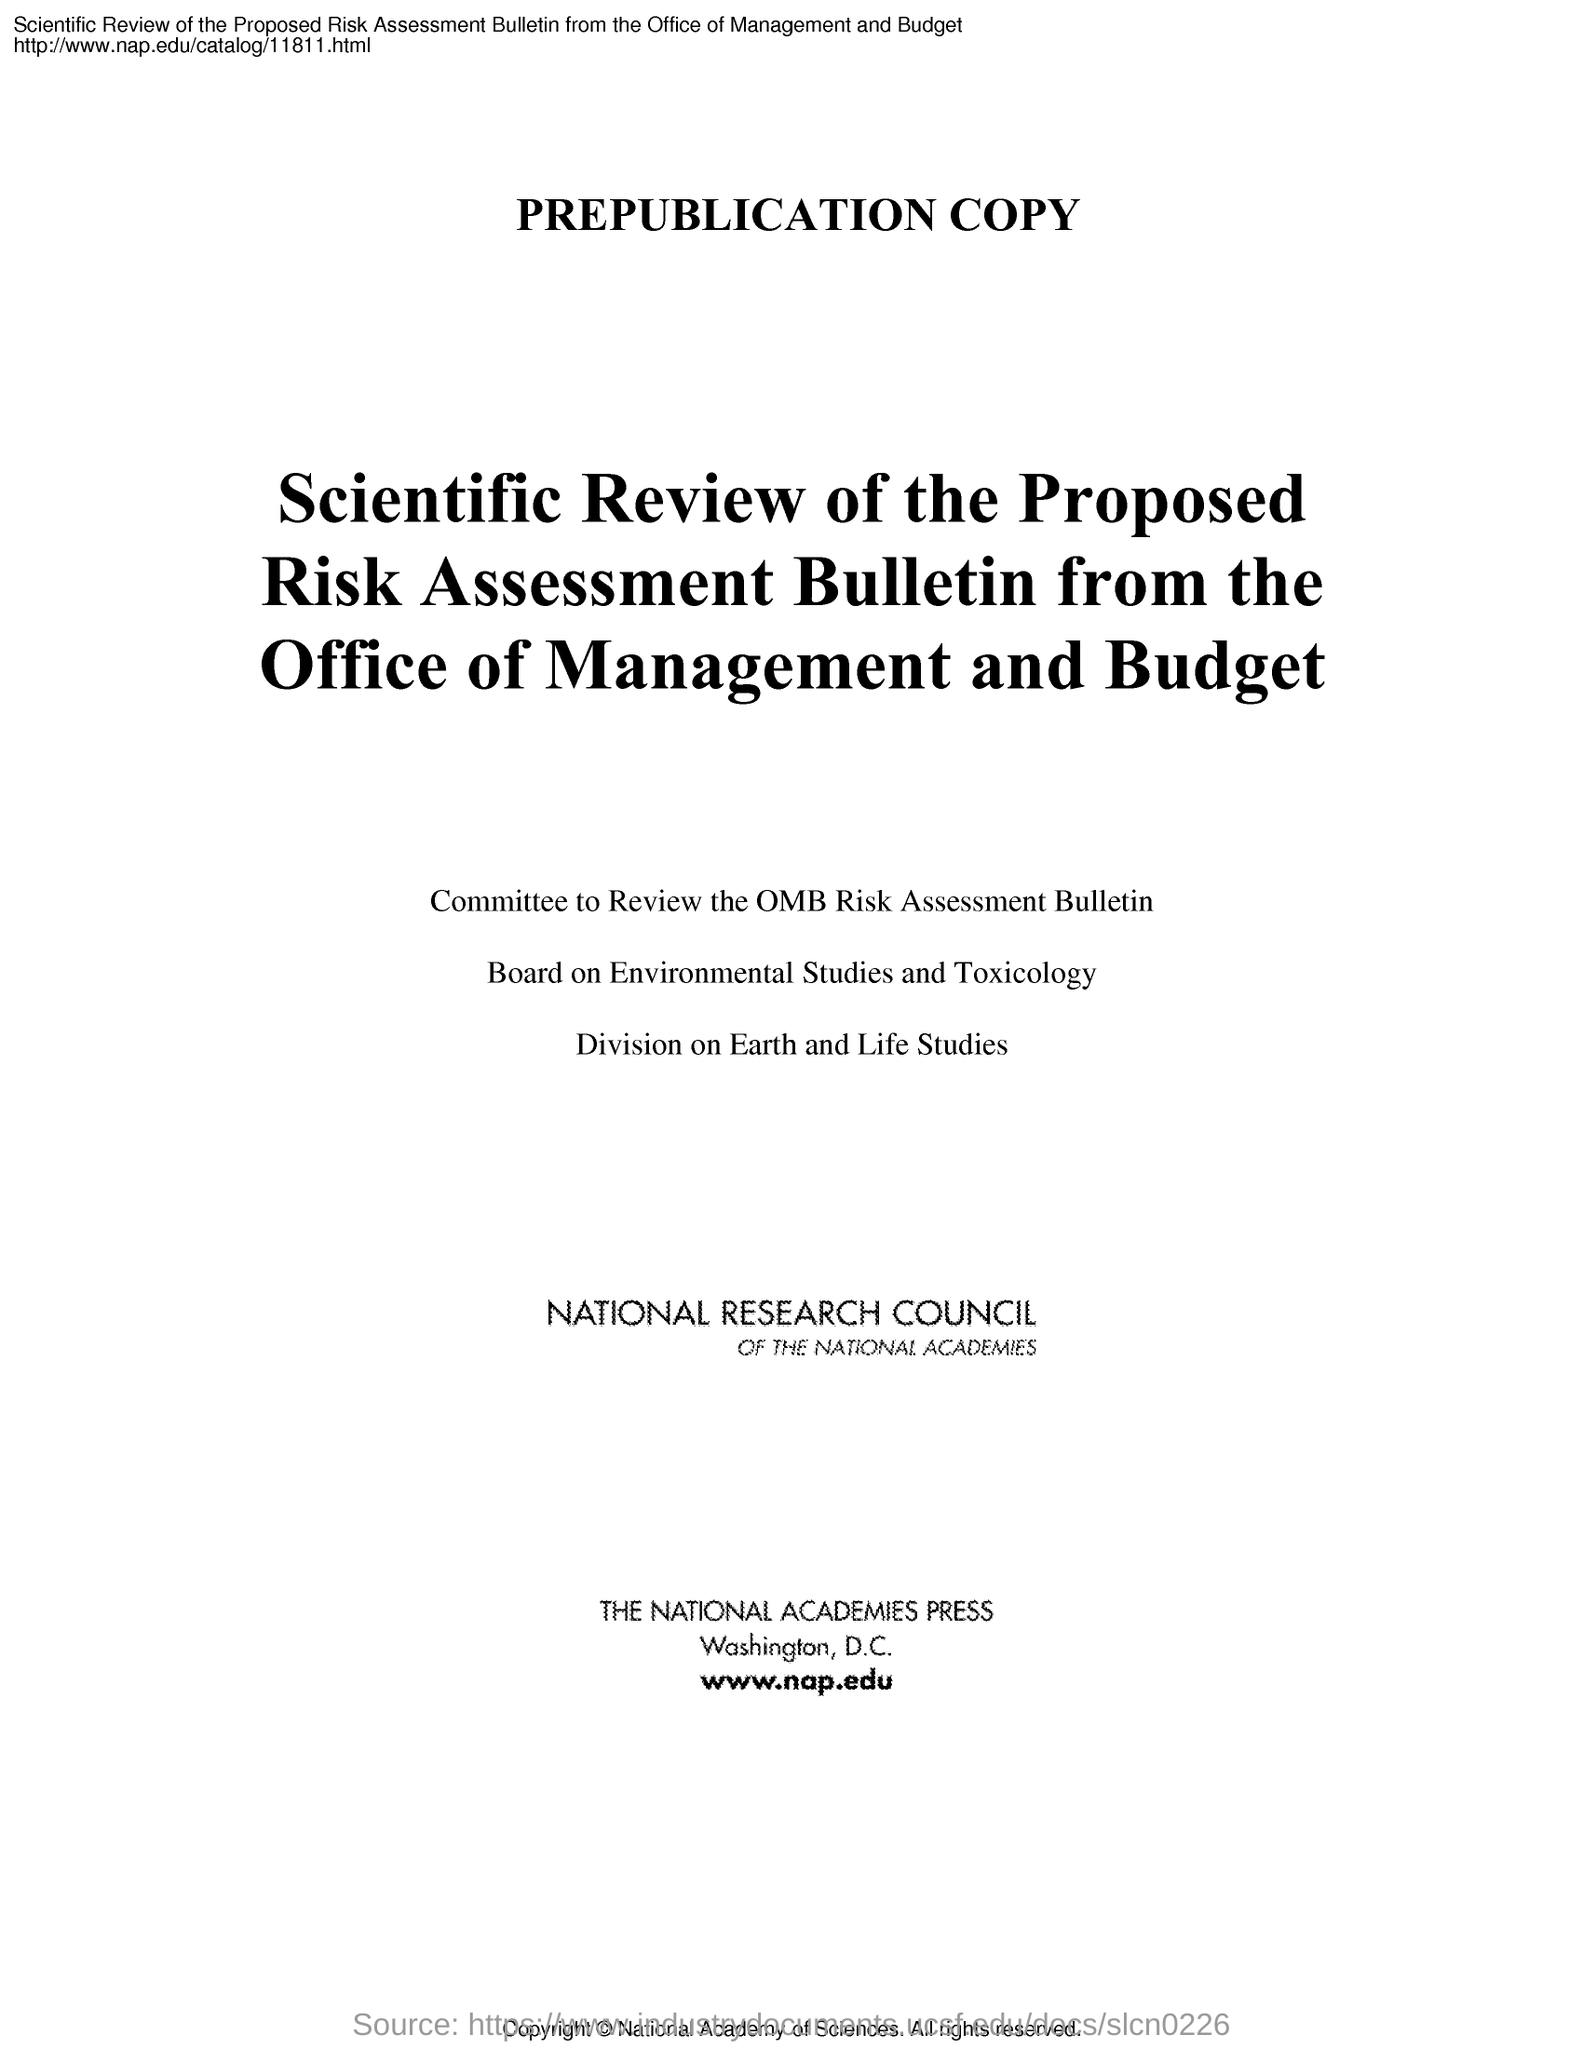Indicate a few pertinent items in this graphic. The National Academic Press is located in Washington, D.C. The first heading in the document is 'Prepublication Copy.' The main heading of the document is "Scientific Review of the Proposed Risk Assessment Bulletin from the Office of Management and Budget. 